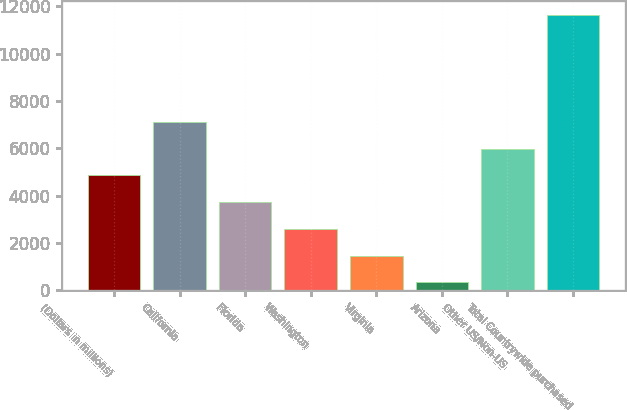Convert chart to OTSL. <chart><loc_0><loc_0><loc_500><loc_500><bar_chart><fcel>(Dollars in millions)<fcel>California<fcel>Florida<fcel>Washington<fcel>Virginia<fcel>Arizona<fcel>Other US/Non-US<fcel>Total Countrywide purchased<nl><fcel>4864.2<fcel>7126.8<fcel>3732.9<fcel>2601.6<fcel>1470.3<fcel>339<fcel>5995.5<fcel>11652<nl></chart> 